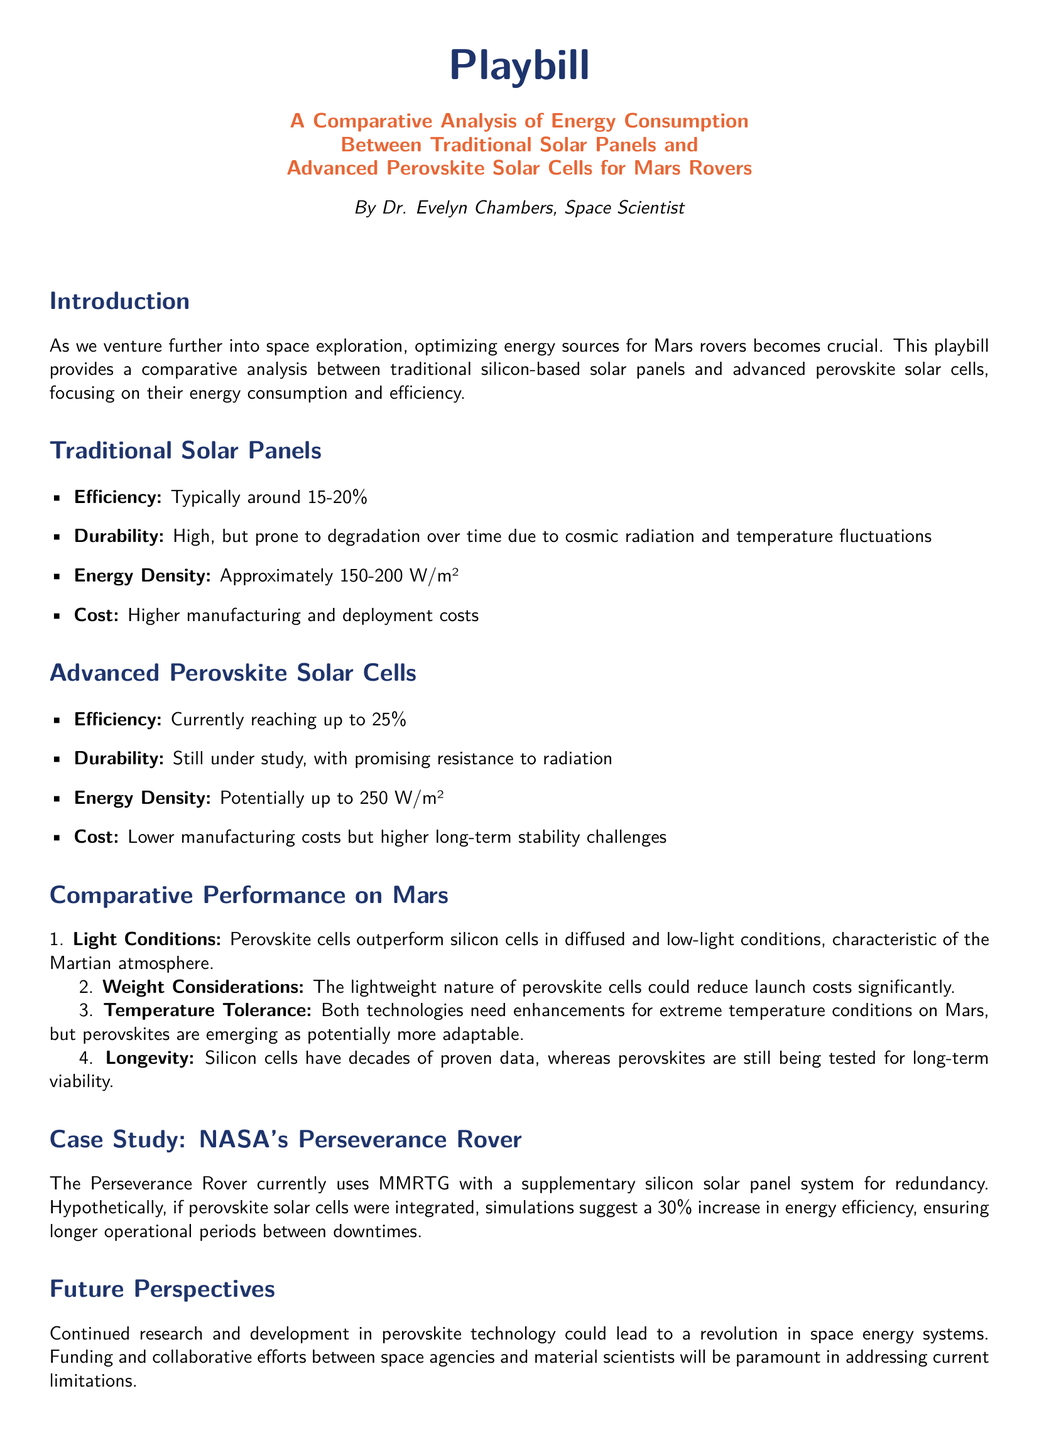What is the typical efficiency of traditional solar panels? The typical efficiency of traditional solar panels is mentioned in the document as ranging from 15 to 20 percent.
Answer: 15-20% What is the energy density of advanced perovskite solar cells? The energy density for advanced perovskite solar cells is stated to be potentially up to 250 W/m² in the document.
Answer: 250 W/m² Who is the author of the playbill? The playbill attributes its authorship to Dr. Evelyn Chambers, a space scientist.
Answer: Dr. Evelyn Chambers What significant increase in energy efficiency does the document suggest for integrating perovskite solar cells into the Perseverance rover? The document suggests a hypothetical 30 percent increase in energy efficiency if perovskite cells were integrated.
Answer: 30% What aspect of perovskite solar cells makes them potentially more viable for Mars? The playbill notes that perovskite cells outperform silicon cells in diffused and low-light conditions characteristic of the Martian atmosphere.
Answer: Low-light conditions What is a noted disadvantage of traditional solar panels regarding durability? Traditional solar panels are noted to be prone to degradation over time due to cosmic radiation and temperature fluctuations.
Answer: Degradation What is the primary focus of the comparative analysis presented in the playbill? The primary focus of the comparative analysis is on energy consumption and efficiency between traditional solar panels and advanced perovskite solar cells.
Answer: Energy consumption and efficiency What is the cost comparison between traditional solar panels and advanced perovskite solar cells? The document states that traditional solar panels have higher manufacturing and deployment costs compared to the lower manufacturing costs of perovskite cells.
Answer: Higher manufacturing costs 